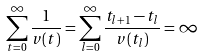Convert formula to latex. <formula><loc_0><loc_0><loc_500><loc_500>\sum _ { t = 0 } ^ { \infty } \frac { 1 } { v ( t ) } = \sum _ { l = 0 } ^ { \infty } \frac { t _ { l + 1 } - t _ { l } } { v ( t _ { l } ) } = \infty</formula> 